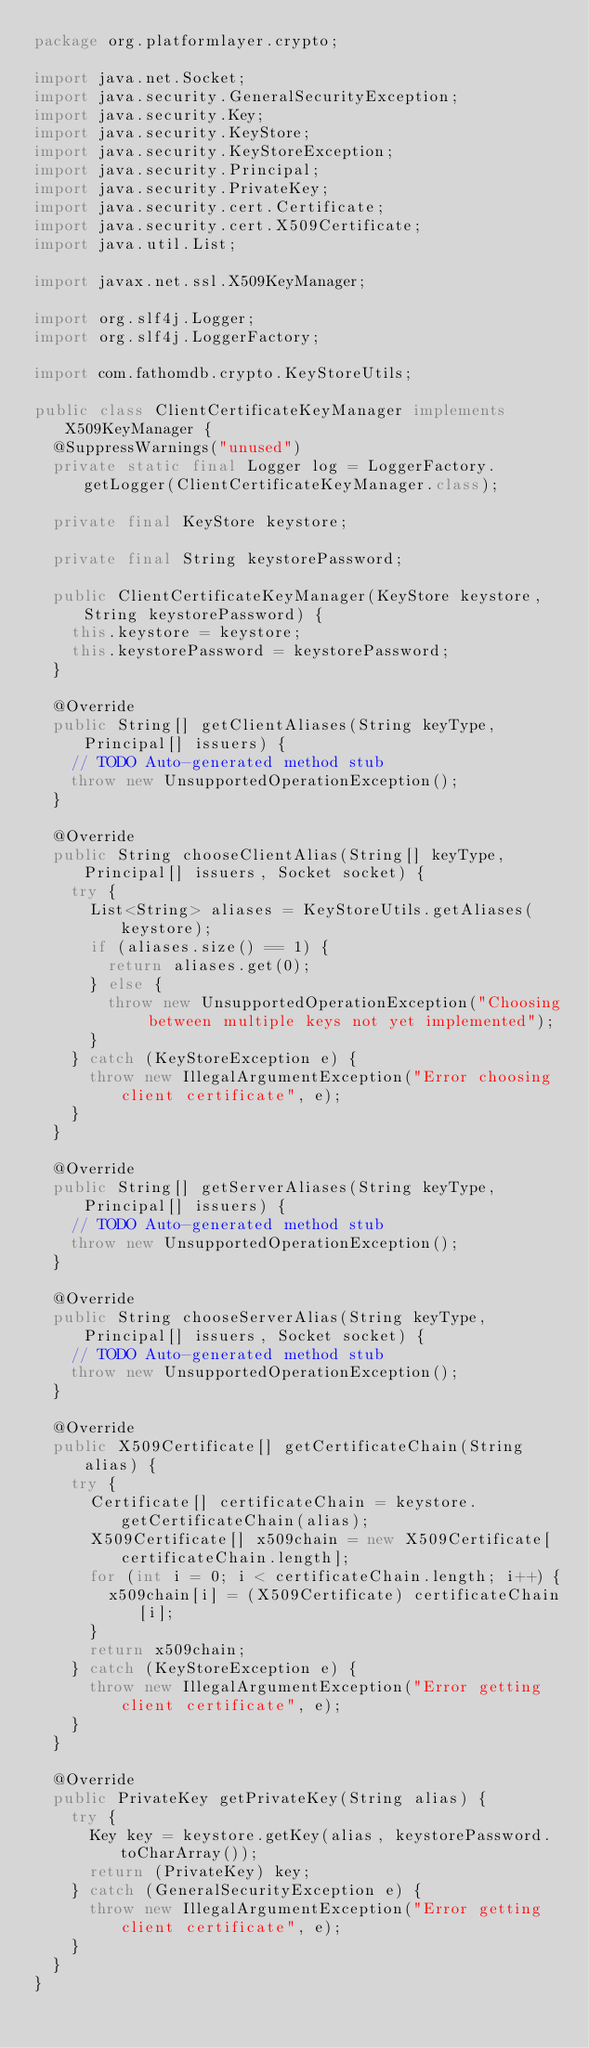Convert code to text. <code><loc_0><loc_0><loc_500><loc_500><_Java_>package org.platformlayer.crypto;

import java.net.Socket;
import java.security.GeneralSecurityException;
import java.security.Key;
import java.security.KeyStore;
import java.security.KeyStoreException;
import java.security.Principal;
import java.security.PrivateKey;
import java.security.cert.Certificate;
import java.security.cert.X509Certificate;
import java.util.List;

import javax.net.ssl.X509KeyManager;

import org.slf4j.Logger;
import org.slf4j.LoggerFactory;

import com.fathomdb.crypto.KeyStoreUtils;

public class ClientCertificateKeyManager implements X509KeyManager {
	@SuppressWarnings("unused")
	private static final Logger log = LoggerFactory.getLogger(ClientCertificateKeyManager.class);

	private final KeyStore keystore;

	private final String keystorePassword;

	public ClientCertificateKeyManager(KeyStore keystore, String keystorePassword) {
		this.keystore = keystore;
		this.keystorePassword = keystorePassword;
	}

	@Override
	public String[] getClientAliases(String keyType, Principal[] issuers) {
		// TODO Auto-generated method stub
		throw new UnsupportedOperationException();
	}

	@Override
	public String chooseClientAlias(String[] keyType, Principal[] issuers, Socket socket) {
		try {
			List<String> aliases = KeyStoreUtils.getAliases(keystore);
			if (aliases.size() == 1) {
				return aliases.get(0);
			} else {
				throw new UnsupportedOperationException("Choosing between multiple keys not yet implemented");
			}
		} catch (KeyStoreException e) {
			throw new IllegalArgumentException("Error choosing client certificate", e);
		}
	}

	@Override
	public String[] getServerAliases(String keyType, Principal[] issuers) {
		// TODO Auto-generated method stub
		throw new UnsupportedOperationException();
	}

	@Override
	public String chooseServerAlias(String keyType, Principal[] issuers, Socket socket) {
		// TODO Auto-generated method stub
		throw new UnsupportedOperationException();
	}

	@Override
	public X509Certificate[] getCertificateChain(String alias) {
		try {
			Certificate[] certificateChain = keystore.getCertificateChain(alias);
			X509Certificate[] x509chain = new X509Certificate[certificateChain.length];
			for (int i = 0; i < certificateChain.length; i++) {
				x509chain[i] = (X509Certificate) certificateChain[i];
			}
			return x509chain;
		} catch (KeyStoreException e) {
			throw new IllegalArgumentException("Error getting client certificate", e);
		}
	}

	@Override
	public PrivateKey getPrivateKey(String alias) {
		try {
			Key key = keystore.getKey(alias, keystorePassword.toCharArray());
			return (PrivateKey) key;
		} catch (GeneralSecurityException e) {
			throw new IllegalArgumentException("Error getting client certificate", e);
		}
	}
}
</code> 